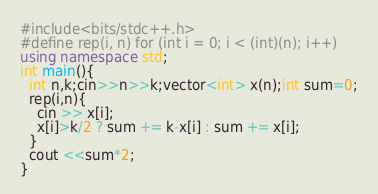Convert code to text. <code><loc_0><loc_0><loc_500><loc_500><_C++_>#include<bits/stdc++.h>
#define rep(i, n) for (int i = 0; i < (int)(n); i++)
using namespace std;
int main(){
  int n,k;cin>>n>>k;vector<int> x(n);int sum=0;
  rep(i,n){
    cin >> x[i];
    x[i]>k/2 ? sum += k-x[i] : sum += x[i]; 
  }
  cout <<sum*2;
}</code> 